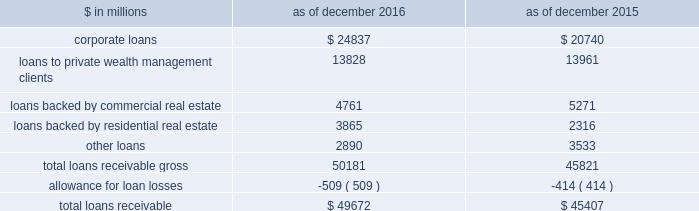The goldman sachs group , inc .
And subsidiaries notes to consolidated financial statements long-term debt instruments the aggregate contractual principal amount of long-term other secured financings for which the fair value option was elected exceeded the related fair value by $ 361 million and $ 362 million as of december 2016 and december 2015 , respectively .
The aggregate contractual principal amount of unsecured long-term borrowings for which the fair value option was elected exceeded the related fair value by $ 1.56 billion and $ 1.12 billion as of december 2016 and december 2015 , respectively .
The amounts above include both principal- and non-principal-protected long-term borrowings .
Impact of credit spreads on loans and lending commitments the estimated net gain attributable to changes in instrument-specific credit spreads on loans and lending commitments for which the fair value option was elected was $ 281 million for 2016 , $ 751 million for 2015 and $ 1.83 billion for 2014 , respectively .
The firm generally calculates the fair value of loans and lending commitments for which the fair value option is elected by discounting future cash flows at a rate which incorporates the instrument-specific credit spreads .
For floating-rate loans and lending commitments , substantially all changes in fair value are attributable to changes in instrument-specific credit spreads , whereas for fixed-rate loans and lending commitments , changes in fair value are also attributable to changes in interest rates .
Debt valuation adjustment the firm calculates the fair value of financial liabilities for which the fair value option is elected by discounting future cash flows at a rate which incorporates the firm 2019s credit spreads .
The net dva on such financial liabilities was a loss of $ 844 million ( $ 544 million , net of tax ) for 2016 and was included in 201cdebt valuation adjustment 201d in the consolidated statements of comprehensive income .
The gains/ ( losses ) reclassified to earnings from accumulated other comprehensive loss upon extinguishment of such financial liabilities were not material for 2016 .
Note 9 .
Loans receivable loans receivable is comprised of loans held for investment that are accounted for at amortized cost net of allowance for loan losses .
Interest on loans receivable is recognized over the life of the loan and is recorded on an accrual basis .
The table below presents details about loans receivable. .
As of december 2016 and december 2015 , the fair value of loans receivable was $ 49.80 billion and $ 45.19 billion , respectively .
As of december 2016 , had these loans been carried at fair value and included in the fair value hierarchy , $ 28.40 billion and $ 21.40 billion would have been classified in level 2 and level 3 , respectively .
As of december 2015 , had these loans been carried at fair value and included in the fair value hierarchy , $ 23.91 billion and $ 21.28 billion would have been classified in level 2 and level 3 , respectively .
The firm also extends lending commitments that are held for investment and accounted for on an accrual basis .
As of december 2016 and december 2015 , such lending commitments were $ 98.05 billion and $ 93.92 billion , respectively .
Substantially all of these commitments were extended to corporate borrowers and were primarily related to the firm 2019s relationship lending activities .
The carrying value and the estimated fair value of such lending commitments were liabilities of $ 327 million and $ 2.55 billion , respectively , as of december 2016 , and $ 291 million and $ 3.32 billion , respectively , as of december 2015 .
As of december 2016 , had these lending commitments been carried at fair value and included in the fair value hierarchy , $ 1.10 billion and $ 1.45 billion would have been classified in level 2 and level 3 , respectively .
As of december 2015 , had these lending commitments been carried at fair value and included in the fair value hierarchy , $ 1.35 billion and $ 1.97 billion would have been classified in level 2 and level 3 , respectively .
Goldman sachs 2016 form 10-k 147 .
What percentage of total loans receivable gross in 2016 were loans backed by commercial real estate? 
Computations: (4761 / 50181)
Answer: 0.09488. The goldman sachs group , inc .
And subsidiaries notes to consolidated financial statements long-term debt instruments the aggregate contractual principal amount of long-term other secured financings for which the fair value option was elected exceeded the related fair value by $ 361 million and $ 362 million as of december 2016 and december 2015 , respectively .
The aggregate contractual principal amount of unsecured long-term borrowings for which the fair value option was elected exceeded the related fair value by $ 1.56 billion and $ 1.12 billion as of december 2016 and december 2015 , respectively .
The amounts above include both principal- and non-principal-protected long-term borrowings .
Impact of credit spreads on loans and lending commitments the estimated net gain attributable to changes in instrument-specific credit spreads on loans and lending commitments for which the fair value option was elected was $ 281 million for 2016 , $ 751 million for 2015 and $ 1.83 billion for 2014 , respectively .
The firm generally calculates the fair value of loans and lending commitments for which the fair value option is elected by discounting future cash flows at a rate which incorporates the instrument-specific credit spreads .
For floating-rate loans and lending commitments , substantially all changes in fair value are attributable to changes in instrument-specific credit spreads , whereas for fixed-rate loans and lending commitments , changes in fair value are also attributable to changes in interest rates .
Debt valuation adjustment the firm calculates the fair value of financial liabilities for which the fair value option is elected by discounting future cash flows at a rate which incorporates the firm 2019s credit spreads .
The net dva on such financial liabilities was a loss of $ 844 million ( $ 544 million , net of tax ) for 2016 and was included in 201cdebt valuation adjustment 201d in the consolidated statements of comprehensive income .
The gains/ ( losses ) reclassified to earnings from accumulated other comprehensive loss upon extinguishment of such financial liabilities were not material for 2016 .
Note 9 .
Loans receivable loans receivable is comprised of loans held for investment that are accounted for at amortized cost net of allowance for loan losses .
Interest on loans receivable is recognized over the life of the loan and is recorded on an accrual basis .
The table below presents details about loans receivable. .
As of december 2016 and december 2015 , the fair value of loans receivable was $ 49.80 billion and $ 45.19 billion , respectively .
As of december 2016 , had these loans been carried at fair value and included in the fair value hierarchy , $ 28.40 billion and $ 21.40 billion would have been classified in level 2 and level 3 , respectively .
As of december 2015 , had these loans been carried at fair value and included in the fair value hierarchy , $ 23.91 billion and $ 21.28 billion would have been classified in level 2 and level 3 , respectively .
The firm also extends lending commitments that are held for investment and accounted for on an accrual basis .
As of december 2016 and december 2015 , such lending commitments were $ 98.05 billion and $ 93.92 billion , respectively .
Substantially all of these commitments were extended to corporate borrowers and were primarily related to the firm 2019s relationship lending activities .
The carrying value and the estimated fair value of such lending commitments were liabilities of $ 327 million and $ 2.55 billion , respectively , as of december 2016 , and $ 291 million and $ 3.32 billion , respectively , as of december 2015 .
As of december 2016 , had these lending commitments been carried at fair value and included in the fair value hierarchy , $ 1.10 billion and $ 1.45 billion would have been classified in level 2 and level 3 , respectively .
As of december 2015 , had these lending commitments been carried at fair value and included in the fair value hierarchy , $ 1.35 billion and $ 1.97 billion would have been classified in level 2 and level 3 , respectively .
Goldman sachs 2016 form 10-k 147 .
For december 2016 and december 2015 , what was total fair value of loans receivable in billions? 
Computations: (49.80 + 45.19)
Answer: 94.99. 